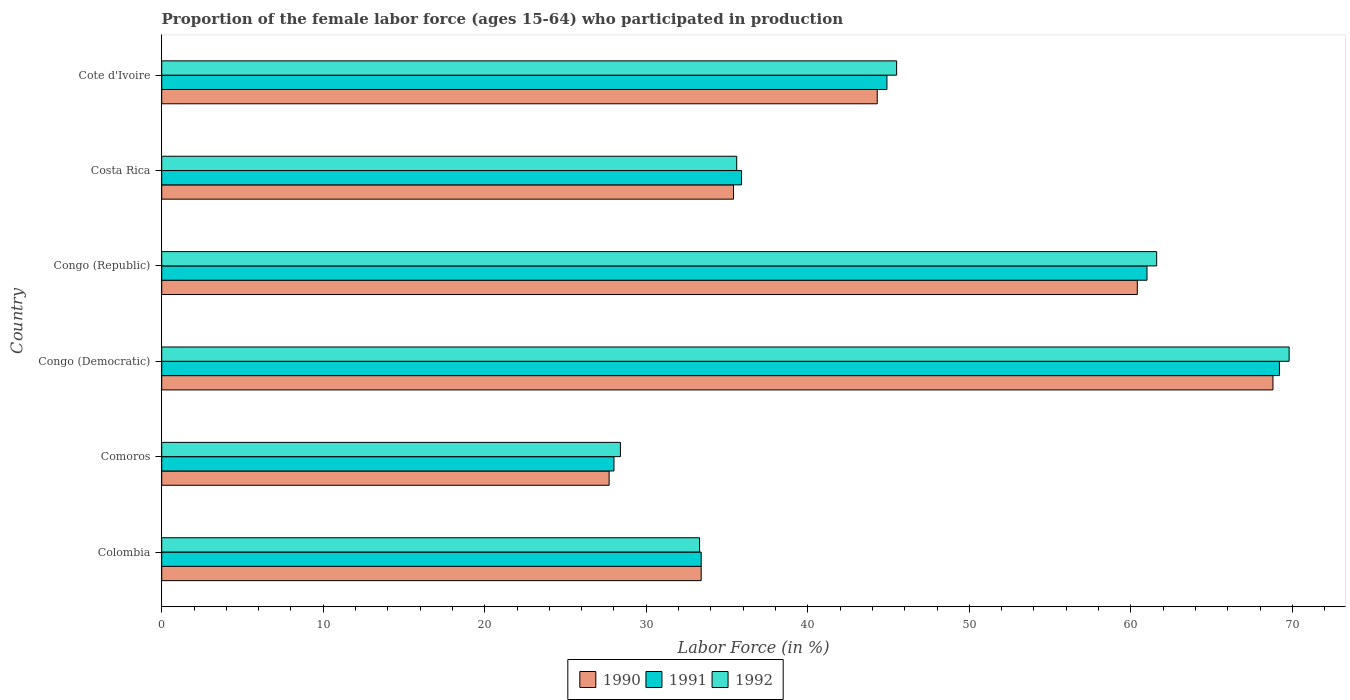How many different coloured bars are there?
Provide a short and direct response. 3. Are the number of bars per tick equal to the number of legend labels?
Your response must be concise. Yes. Are the number of bars on each tick of the Y-axis equal?
Keep it short and to the point. Yes. How many bars are there on the 5th tick from the bottom?
Offer a terse response. 3. What is the proportion of the female labor force who participated in production in 1992 in Cote d'Ivoire?
Offer a very short reply. 45.5. Across all countries, what is the maximum proportion of the female labor force who participated in production in 1992?
Give a very brief answer. 69.8. Across all countries, what is the minimum proportion of the female labor force who participated in production in 1990?
Give a very brief answer. 27.7. In which country was the proportion of the female labor force who participated in production in 1991 maximum?
Give a very brief answer. Congo (Democratic). In which country was the proportion of the female labor force who participated in production in 1992 minimum?
Ensure brevity in your answer.  Comoros. What is the total proportion of the female labor force who participated in production in 1991 in the graph?
Ensure brevity in your answer.  272.4. What is the difference between the proportion of the female labor force who participated in production in 1992 in Congo (Republic) and that in Costa Rica?
Offer a very short reply. 26. What is the difference between the proportion of the female labor force who participated in production in 1990 in Congo (Democratic) and the proportion of the female labor force who participated in production in 1992 in Costa Rica?
Your answer should be very brief. 33.2. What is the average proportion of the female labor force who participated in production in 1991 per country?
Give a very brief answer. 45.4. What is the difference between the proportion of the female labor force who participated in production in 1992 and proportion of the female labor force who participated in production in 1991 in Congo (Democratic)?
Offer a very short reply. 0.6. In how many countries, is the proportion of the female labor force who participated in production in 1990 greater than 66 %?
Offer a terse response. 1. What is the ratio of the proportion of the female labor force who participated in production in 1992 in Colombia to that in Cote d'Ivoire?
Ensure brevity in your answer.  0.73. What is the difference between the highest and the second highest proportion of the female labor force who participated in production in 1991?
Your answer should be compact. 8.2. What is the difference between the highest and the lowest proportion of the female labor force who participated in production in 1991?
Your answer should be very brief. 41.2. In how many countries, is the proportion of the female labor force who participated in production in 1991 greater than the average proportion of the female labor force who participated in production in 1991 taken over all countries?
Keep it short and to the point. 2. Is the sum of the proportion of the female labor force who participated in production in 1992 in Colombia and Congo (Republic) greater than the maximum proportion of the female labor force who participated in production in 1991 across all countries?
Your answer should be compact. Yes. What does the 3rd bar from the top in Cote d'Ivoire represents?
Your answer should be very brief. 1990. What does the 2nd bar from the bottom in Cote d'Ivoire represents?
Your response must be concise. 1991. Are all the bars in the graph horizontal?
Provide a short and direct response. Yes. How many countries are there in the graph?
Your answer should be very brief. 6. What is the difference between two consecutive major ticks on the X-axis?
Your answer should be compact. 10. Are the values on the major ticks of X-axis written in scientific E-notation?
Provide a succinct answer. No. Does the graph contain any zero values?
Your response must be concise. No. How many legend labels are there?
Ensure brevity in your answer.  3. What is the title of the graph?
Keep it short and to the point. Proportion of the female labor force (ages 15-64) who participated in production. Does "1976" appear as one of the legend labels in the graph?
Give a very brief answer. No. What is the label or title of the X-axis?
Ensure brevity in your answer.  Labor Force (in %). What is the label or title of the Y-axis?
Your response must be concise. Country. What is the Labor Force (in %) of 1990 in Colombia?
Your answer should be very brief. 33.4. What is the Labor Force (in %) in 1991 in Colombia?
Provide a short and direct response. 33.4. What is the Labor Force (in %) of 1992 in Colombia?
Your answer should be very brief. 33.3. What is the Labor Force (in %) of 1990 in Comoros?
Offer a very short reply. 27.7. What is the Labor Force (in %) of 1992 in Comoros?
Provide a short and direct response. 28.4. What is the Labor Force (in %) in 1990 in Congo (Democratic)?
Give a very brief answer. 68.8. What is the Labor Force (in %) of 1991 in Congo (Democratic)?
Your answer should be compact. 69.2. What is the Labor Force (in %) in 1992 in Congo (Democratic)?
Keep it short and to the point. 69.8. What is the Labor Force (in %) of 1990 in Congo (Republic)?
Ensure brevity in your answer.  60.4. What is the Labor Force (in %) in 1991 in Congo (Republic)?
Your response must be concise. 61. What is the Labor Force (in %) in 1992 in Congo (Republic)?
Ensure brevity in your answer.  61.6. What is the Labor Force (in %) in 1990 in Costa Rica?
Offer a terse response. 35.4. What is the Labor Force (in %) of 1991 in Costa Rica?
Your answer should be compact. 35.9. What is the Labor Force (in %) in 1992 in Costa Rica?
Provide a succinct answer. 35.6. What is the Labor Force (in %) in 1990 in Cote d'Ivoire?
Your answer should be compact. 44.3. What is the Labor Force (in %) of 1991 in Cote d'Ivoire?
Give a very brief answer. 44.9. What is the Labor Force (in %) in 1992 in Cote d'Ivoire?
Give a very brief answer. 45.5. Across all countries, what is the maximum Labor Force (in %) of 1990?
Keep it short and to the point. 68.8. Across all countries, what is the maximum Labor Force (in %) of 1991?
Provide a short and direct response. 69.2. Across all countries, what is the maximum Labor Force (in %) of 1992?
Your response must be concise. 69.8. Across all countries, what is the minimum Labor Force (in %) of 1990?
Provide a succinct answer. 27.7. Across all countries, what is the minimum Labor Force (in %) of 1992?
Make the answer very short. 28.4. What is the total Labor Force (in %) of 1990 in the graph?
Provide a short and direct response. 270. What is the total Labor Force (in %) in 1991 in the graph?
Your answer should be compact. 272.4. What is the total Labor Force (in %) in 1992 in the graph?
Your response must be concise. 274.2. What is the difference between the Labor Force (in %) in 1990 in Colombia and that in Comoros?
Provide a succinct answer. 5.7. What is the difference between the Labor Force (in %) of 1992 in Colombia and that in Comoros?
Your response must be concise. 4.9. What is the difference between the Labor Force (in %) of 1990 in Colombia and that in Congo (Democratic)?
Your answer should be very brief. -35.4. What is the difference between the Labor Force (in %) in 1991 in Colombia and that in Congo (Democratic)?
Offer a terse response. -35.8. What is the difference between the Labor Force (in %) in 1992 in Colombia and that in Congo (Democratic)?
Offer a very short reply. -36.5. What is the difference between the Labor Force (in %) of 1990 in Colombia and that in Congo (Republic)?
Offer a terse response. -27. What is the difference between the Labor Force (in %) of 1991 in Colombia and that in Congo (Republic)?
Keep it short and to the point. -27.6. What is the difference between the Labor Force (in %) in 1992 in Colombia and that in Congo (Republic)?
Offer a very short reply. -28.3. What is the difference between the Labor Force (in %) in 1992 in Colombia and that in Costa Rica?
Give a very brief answer. -2.3. What is the difference between the Labor Force (in %) in 1990 in Colombia and that in Cote d'Ivoire?
Give a very brief answer. -10.9. What is the difference between the Labor Force (in %) of 1991 in Colombia and that in Cote d'Ivoire?
Provide a short and direct response. -11.5. What is the difference between the Labor Force (in %) of 1992 in Colombia and that in Cote d'Ivoire?
Provide a short and direct response. -12.2. What is the difference between the Labor Force (in %) in 1990 in Comoros and that in Congo (Democratic)?
Provide a succinct answer. -41.1. What is the difference between the Labor Force (in %) in 1991 in Comoros and that in Congo (Democratic)?
Ensure brevity in your answer.  -41.2. What is the difference between the Labor Force (in %) of 1992 in Comoros and that in Congo (Democratic)?
Provide a short and direct response. -41.4. What is the difference between the Labor Force (in %) of 1990 in Comoros and that in Congo (Republic)?
Provide a succinct answer. -32.7. What is the difference between the Labor Force (in %) of 1991 in Comoros and that in Congo (Republic)?
Make the answer very short. -33. What is the difference between the Labor Force (in %) of 1992 in Comoros and that in Congo (Republic)?
Your response must be concise. -33.2. What is the difference between the Labor Force (in %) of 1991 in Comoros and that in Costa Rica?
Your response must be concise. -7.9. What is the difference between the Labor Force (in %) in 1990 in Comoros and that in Cote d'Ivoire?
Give a very brief answer. -16.6. What is the difference between the Labor Force (in %) of 1991 in Comoros and that in Cote d'Ivoire?
Provide a short and direct response. -16.9. What is the difference between the Labor Force (in %) of 1992 in Comoros and that in Cote d'Ivoire?
Your answer should be compact. -17.1. What is the difference between the Labor Force (in %) in 1991 in Congo (Democratic) and that in Congo (Republic)?
Your response must be concise. 8.2. What is the difference between the Labor Force (in %) in 1990 in Congo (Democratic) and that in Costa Rica?
Provide a short and direct response. 33.4. What is the difference between the Labor Force (in %) in 1991 in Congo (Democratic) and that in Costa Rica?
Provide a short and direct response. 33.3. What is the difference between the Labor Force (in %) of 1992 in Congo (Democratic) and that in Costa Rica?
Offer a very short reply. 34.2. What is the difference between the Labor Force (in %) in 1991 in Congo (Democratic) and that in Cote d'Ivoire?
Your answer should be compact. 24.3. What is the difference between the Labor Force (in %) of 1992 in Congo (Democratic) and that in Cote d'Ivoire?
Ensure brevity in your answer.  24.3. What is the difference between the Labor Force (in %) of 1991 in Congo (Republic) and that in Costa Rica?
Provide a succinct answer. 25.1. What is the difference between the Labor Force (in %) in 1990 in Costa Rica and that in Cote d'Ivoire?
Your response must be concise. -8.9. What is the difference between the Labor Force (in %) in 1990 in Colombia and the Labor Force (in %) in 1992 in Comoros?
Offer a terse response. 5. What is the difference between the Labor Force (in %) in 1990 in Colombia and the Labor Force (in %) in 1991 in Congo (Democratic)?
Offer a very short reply. -35.8. What is the difference between the Labor Force (in %) of 1990 in Colombia and the Labor Force (in %) of 1992 in Congo (Democratic)?
Your answer should be very brief. -36.4. What is the difference between the Labor Force (in %) of 1991 in Colombia and the Labor Force (in %) of 1992 in Congo (Democratic)?
Your response must be concise. -36.4. What is the difference between the Labor Force (in %) in 1990 in Colombia and the Labor Force (in %) in 1991 in Congo (Republic)?
Keep it short and to the point. -27.6. What is the difference between the Labor Force (in %) in 1990 in Colombia and the Labor Force (in %) in 1992 in Congo (Republic)?
Offer a terse response. -28.2. What is the difference between the Labor Force (in %) in 1991 in Colombia and the Labor Force (in %) in 1992 in Congo (Republic)?
Keep it short and to the point. -28.2. What is the difference between the Labor Force (in %) of 1990 in Colombia and the Labor Force (in %) of 1992 in Cote d'Ivoire?
Your response must be concise. -12.1. What is the difference between the Labor Force (in %) of 1991 in Colombia and the Labor Force (in %) of 1992 in Cote d'Ivoire?
Your answer should be compact. -12.1. What is the difference between the Labor Force (in %) of 1990 in Comoros and the Labor Force (in %) of 1991 in Congo (Democratic)?
Provide a short and direct response. -41.5. What is the difference between the Labor Force (in %) of 1990 in Comoros and the Labor Force (in %) of 1992 in Congo (Democratic)?
Offer a terse response. -42.1. What is the difference between the Labor Force (in %) in 1991 in Comoros and the Labor Force (in %) in 1992 in Congo (Democratic)?
Provide a short and direct response. -41.8. What is the difference between the Labor Force (in %) of 1990 in Comoros and the Labor Force (in %) of 1991 in Congo (Republic)?
Offer a very short reply. -33.3. What is the difference between the Labor Force (in %) in 1990 in Comoros and the Labor Force (in %) in 1992 in Congo (Republic)?
Provide a succinct answer. -33.9. What is the difference between the Labor Force (in %) in 1991 in Comoros and the Labor Force (in %) in 1992 in Congo (Republic)?
Your answer should be compact. -33.6. What is the difference between the Labor Force (in %) in 1990 in Comoros and the Labor Force (in %) in 1992 in Costa Rica?
Provide a succinct answer. -7.9. What is the difference between the Labor Force (in %) in 1991 in Comoros and the Labor Force (in %) in 1992 in Costa Rica?
Your answer should be compact. -7.6. What is the difference between the Labor Force (in %) of 1990 in Comoros and the Labor Force (in %) of 1991 in Cote d'Ivoire?
Your answer should be very brief. -17.2. What is the difference between the Labor Force (in %) in 1990 in Comoros and the Labor Force (in %) in 1992 in Cote d'Ivoire?
Make the answer very short. -17.8. What is the difference between the Labor Force (in %) of 1991 in Comoros and the Labor Force (in %) of 1992 in Cote d'Ivoire?
Keep it short and to the point. -17.5. What is the difference between the Labor Force (in %) of 1990 in Congo (Democratic) and the Labor Force (in %) of 1991 in Congo (Republic)?
Offer a terse response. 7.8. What is the difference between the Labor Force (in %) in 1990 in Congo (Democratic) and the Labor Force (in %) in 1992 in Congo (Republic)?
Offer a terse response. 7.2. What is the difference between the Labor Force (in %) of 1991 in Congo (Democratic) and the Labor Force (in %) of 1992 in Congo (Republic)?
Keep it short and to the point. 7.6. What is the difference between the Labor Force (in %) in 1990 in Congo (Democratic) and the Labor Force (in %) in 1991 in Costa Rica?
Give a very brief answer. 32.9. What is the difference between the Labor Force (in %) of 1990 in Congo (Democratic) and the Labor Force (in %) of 1992 in Costa Rica?
Provide a short and direct response. 33.2. What is the difference between the Labor Force (in %) of 1991 in Congo (Democratic) and the Labor Force (in %) of 1992 in Costa Rica?
Ensure brevity in your answer.  33.6. What is the difference between the Labor Force (in %) of 1990 in Congo (Democratic) and the Labor Force (in %) of 1991 in Cote d'Ivoire?
Offer a terse response. 23.9. What is the difference between the Labor Force (in %) of 1990 in Congo (Democratic) and the Labor Force (in %) of 1992 in Cote d'Ivoire?
Provide a short and direct response. 23.3. What is the difference between the Labor Force (in %) of 1991 in Congo (Democratic) and the Labor Force (in %) of 1992 in Cote d'Ivoire?
Offer a very short reply. 23.7. What is the difference between the Labor Force (in %) of 1990 in Congo (Republic) and the Labor Force (in %) of 1991 in Costa Rica?
Offer a terse response. 24.5. What is the difference between the Labor Force (in %) of 1990 in Congo (Republic) and the Labor Force (in %) of 1992 in Costa Rica?
Offer a very short reply. 24.8. What is the difference between the Labor Force (in %) of 1991 in Congo (Republic) and the Labor Force (in %) of 1992 in Costa Rica?
Offer a terse response. 25.4. What is the difference between the Labor Force (in %) of 1990 in Congo (Republic) and the Labor Force (in %) of 1992 in Cote d'Ivoire?
Keep it short and to the point. 14.9. What is the difference between the Labor Force (in %) of 1991 in Congo (Republic) and the Labor Force (in %) of 1992 in Cote d'Ivoire?
Provide a succinct answer. 15.5. What is the difference between the Labor Force (in %) of 1990 in Costa Rica and the Labor Force (in %) of 1991 in Cote d'Ivoire?
Your answer should be compact. -9.5. What is the difference between the Labor Force (in %) of 1991 in Costa Rica and the Labor Force (in %) of 1992 in Cote d'Ivoire?
Your response must be concise. -9.6. What is the average Labor Force (in %) in 1990 per country?
Keep it short and to the point. 45. What is the average Labor Force (in %) of 1991 per country?
Your response must be concise. 45.4. What is the average Labor Force (in %) of 1992 per country?
Ensure brevity in your answer.  45.7. What is the difference between the Labor Force (in %) in 1990 and Labor Force (in %) in 1991 in Colombia?
Your answer should be compact. 0. What is the difference between the Labor Force (in %) of 1990 and Labor Force (in %) of 1992 in Colombia?
Offer a terse response. 0.1. What is the difference between the Labor Force (in %) in 1991 and Labor Force (in %) in 1992 in Colombia?
Provide a short and direct response. 0.1. What is the difference between the Labor Force (in %) in 1990 and Labor Force (in %) in 1991 in Comoros?
Offer a terse response. -0.3. What is the difference between the Labor Force (in %) in 1991 and Labor Force (in %) in 1992 in Comoros?
Provide a succinct answer. -0.4. What is the difference between the Labor Force (in %) in 1990 and Labor Force (in %) in 1991 in Congo (Democratic)?
Your answer should be compact. -0.4. What is the difference between the Labor Force (in %) in 1990 and Labor Force (in %) in 1992 in Congo (Democratic)?
Make the answer very short. -1. What is the difference between the Labor Force (in %) in 1991 and Labor Force (in %) in 1992 in Congo (Democratic)?
Make the answer very short. -0.6. What is the difference between the Labor Force (in %) in 1990 and Labor Force (in %) in 1991 in Congo (Republic)?
Offer a very short reply. -0.6. What is the difference between the Labor Force (in %) in 1990 and Labor Force (in %) in 1992 in Congo (Republic)?
Your answer should be compact. -1.2. What is the difference between the Labor Force (in %) in 1991 and Labor Force (in %) in 1992 in Congo (Republic)?
Keep it short and to the point. -0.6. What is the difference between the Labor Force (in %) in 1990 and Labor Force (in %) in 1992 in Costa Rica?
Provide a succinct answer. -0.2. What is the difference between the Labor Force (in %) in 1990 and Labor Force (in %) in 1991 in Cote d'Ivoire?
Ensure brevity in your answer.  -0.6. What is the difference between the Labor Force (in %) of 1991 and Labor Force (in %) of 1992 in Cote d'Ivoire?
Offer a very short reply. -0.6. What is the ratio of the Labor Force (in %) of 1990 in Colombia to that in Comoros?
Keep it short and to the point. 1.21. What is the ratio of the Labor Force (in %) of 1991 in Colombia to that in Comoros?
Ensure brevity in your answer.  1.19. What is the ratio of the Labor Force (in %) in 1992 in Colombia to that in Comoros?
Offer a very short reply. 1.17. What is the ratio of the Labor Force (in %) in 1990 in Colombia to that in Congo (Democratic)?
Give a very brief answer. 0.49. What is the ratio of the Labor Force (in %) of 1991 in Colombia to that in Congo (Democratic)?
Offer a very short reply. 0.48. What is the ratio of the Labor Force (in %) in 1992 in Colombia to that in Congo (Democratic)?
Your answer should be compact. 0.48. What is the ratio of the Labor Force (in %) in 1990 in Colombia to that in Congo (Republic)?
Give a very brief answer. 0.55. What is the ratio of the Labor Force (in %) of 1991 in Colombia to that in Congo (Republic)?
Provide a short and direct response. 0.55. What is the ratio of the Labor Force (in %) in 1992 in Colombia to that in Congo (Republic)?
Offer a very short reply. 0.54. What is the ratio of the Labor Force (in %) of 1990 in Colombia to that in Costa Rica?
Your answer should be compact. 0.94. What is the ratio of the Labor Force (in %) of 1991 in Colombia to that in Costa Rica?
Offer a terse response. 0.93. What is the ratio of the Labor Force (in %) of 1992 in Colombia to that in Costa Rica?
Offer a very short reply. 0.94. What is the ratio of the Labor Force (in %) of 1990 in Colombia to that in Cote d'Ivoire?
Your answer should be compact. 0.75. What is the ratio of the Labor Force (in %) of 1991 in Colombia to that in Cote d'Ivoire?
Ensure brevity in your answer.  0.74. What is the ratio of the Labor Force (in %) of 1992 in Colombia to that in Cote d'Ivoire?
Offer a terse response. 0.73. What is the ratio of the Labor Force (in %) in 1990 in Comoros to that in Congo (Democratic)?
Your answer should be very brief. 0.4. What is the ratio of the Labor Force (in %) of 1991 in Comoros to that in Congo (Democratic)?
Offer a very short reply. 0.4. What is the ratio of the Labor Force (in %) in 1992 in Comoros to that in Congo (Democratic)?
Your answer should be compact. 0.41. What is the ratio of the Labor Force (in %) of 1990 in Comoros to that in Congo (Republic)?
Provide a short and direct response. 0.46. What is the ratio of the Labor Force (in %) of 1991 in Comoros to that in Congo (Republic)?
Keep it short and to the point. 0.46. What is the ratio of the Labor Force (in %) of 1992 in Comoros to that in Congo (Republic)?
Offer a very short reply. 0.46. What is the ratio of the Labor Force (in %) in 1990 in Comoros to that in Costa Rica?
Your answer should be compact. 0.78. What is the ratio of the Labor Force (in %) of 1991 in Comoros to that in Costa Rica?
Provide a short and direct response. 0.78. What is the ratio of the Labor Force (in %) of 1992 in Comoros to that in Costa Rica?
Your answer should be compact. 0.8. What is the ratio of the Labor Force (in %) of 1990 in Comoros to that in Cote d'Ivoire?
Provide a short and direct response. 0.63. What is the ratio of the Labor Force (in %) of 1991 in Comoros to that in Cote d'Ivoire?
Make the answer very short. 0.62. What is the ratio of the Labor Force (in %) of 1992 in Comoros to that in Cote d'Ivoire?
Give a very brief answer. 0.62. What is the ratio of the Labor Force (in %) of 1990 in Congo (Democratic) to that in Congo (Republic)?
Provide a succinct answer. 1.14. What is the ratio of the Labor Force (in %) of 1991 in Congo (Democratic) to that in Congo (Republic)?
Offer a very short reply. 1.13. What is the ratio of the Labor Force (in %) of 1992 in Congo (Democratic) to that in Congo (Republic)?
Your response must be concise. 1.13. What is the ratio of the Labor Force (in %) of 1990 in Congo (Democratic) to that in Costa Rica?
Your answer should be very brief. 1.94. What is the ratio of the Labor Force (in %) of 1991 in Congo (Democratic) to that in Costa Rica?
Offer a very short reply. 1.93. What is the ratio of the Labor Force (in %) of 1992 in Congo (Democratic) to that in Costa Rica?
Make the answer very short. 1.96. What is the ratio of the Labor Force (in %) of 1990 in Congo (Democratic) to that in Cote d'Ivoire?
Keep it short and to the point. 1.55. What is the ratio of the Labor Force (in %) of 1991 in Congo (Democratic) to that in Cote d'Ivoire?
Provide a succinct answer. 1.54. What is the ratio of the Labor Force (in %) of 1992 in Congo (Democratic) to that in Cote d'Ivoire?
Offer a very short reply. 1.53. What is the ratio of the Labor Force (in %) of 1990 in Congo (Republic) to that in Costa Rica?
Your answer should be compact. 1.71. What is the ratio of the Labor Force (in %) in 1991 in Congo (Republic) to that in Costa Rica?
Ensure brevity in your answer.  1.7. What is the ratio of the Labor Force (in %) in 1992 in Congo (Republic) to that in Costa Rica?
Ensure brevity in your answer.  1.73. What is the ratio of the Labor Force (in %) in 1990 in Congo (Republic) to that in Cote d'Ivoire?
Make the answer very short. 1.36. What is the ratio of the Labor Force (in %) of 1991 in Congo (Republic) to that in Cote d'Ivoire?
Your response must be concise. 1.36. What is the ratio of the Labor Force (in %) in 1992 in Congo (Republic) to that in Cote d'Ivoire?
Offer a very short reply. 1.35. What is the ratio of the Labor Force (in %) of 1990 in Costa Rica to that in Cote d'Ivoire?
Your response must be concise. 0.8. What is the ratio of the Labor Force (in %) in 1991 in Costa Rica to that in Cote d'Ivoire?
Ensure brevity in your answer.  0.8. What is the ratio of the Labor Force (in %) in 1992 in Costa Rica to that in Cote d'Ivoire?
Give a very brief answer. 0.78. What is the difference between the highest and the second highest Labor Force (in %) of 1992?
Your response must be concise. 8.2. What is the difference between the highest and the lowest Labor Force (in %) of 1990?
Your response must be concise. 41.1. What is the difference between the highest and the lowest Labor Force (in %) of 1991?
Your response must be concise. 41.2. What is the difference between the highest and the lowest Labor Force (in %) in 1992?
Your response must be concise. 41.4. 